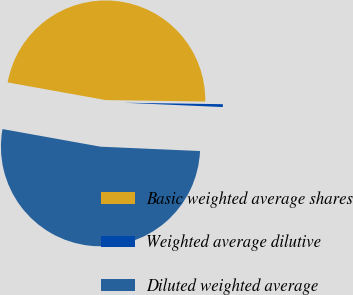Convert chart. <chart><loc_0><loc_0><loc_500><loc_500><pie_chart><fcel>Basic weighted average shares<fcel>Weighted average dilutive<fcel>Diluted weighted average<nl><fcel>47.4%<fcel>0.46%<fcel>52.14%<nl></chart> 